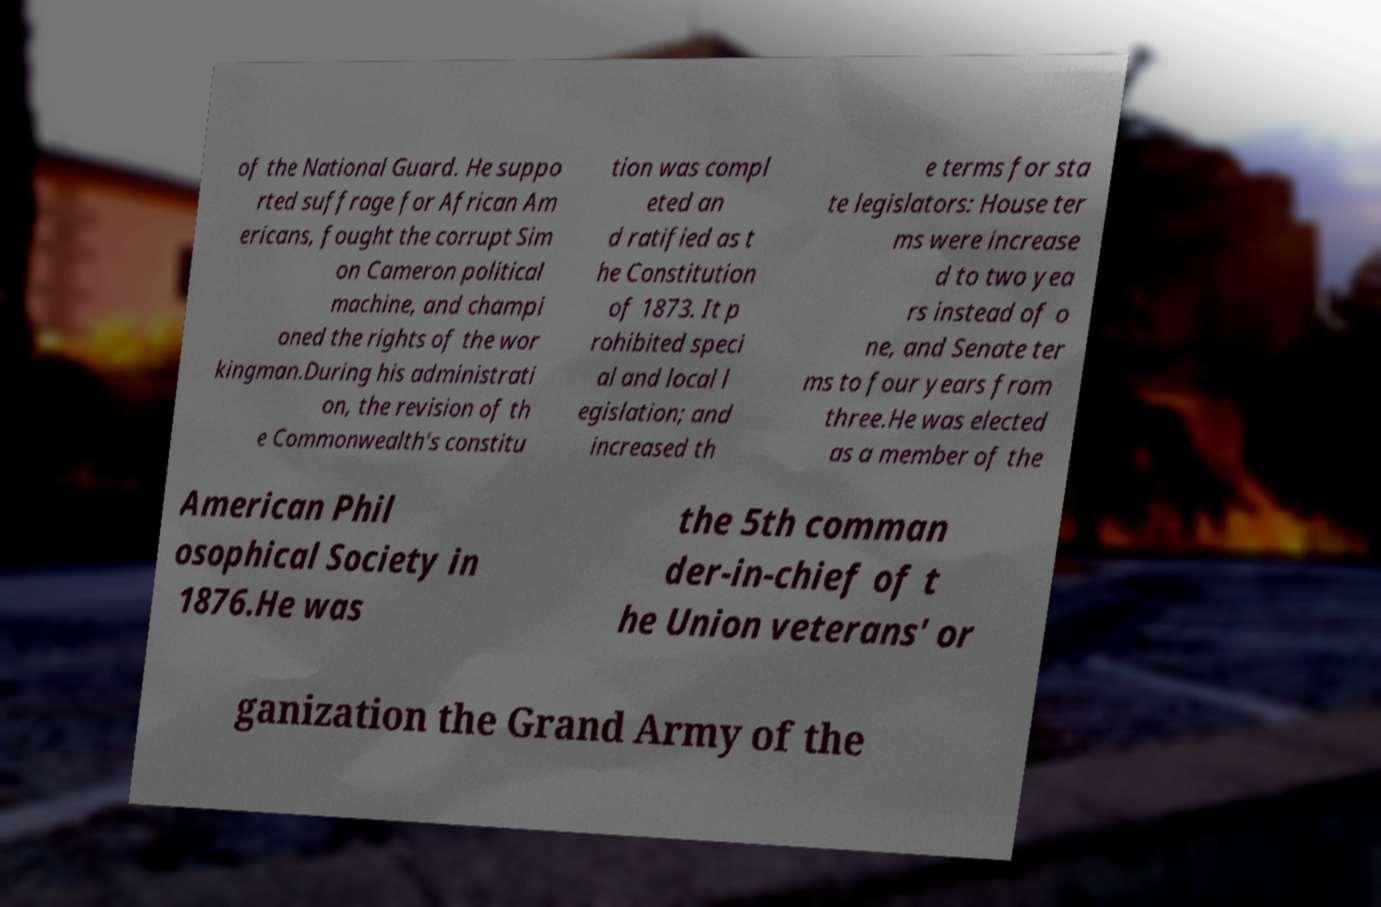I need the written content from this picture converted into text. Can you do that? of the National Guard. He suppo rted suffrage for African Am ericans, fought the corrupt Sim on Cameron political machine, and champi oned the rights of the wor kingman.During his administrati on, the revision of th e Commonwealth's constitu tion was compl eted an d ratified as t he Constitution of 1873. It p rohibited speci al and local l egislation; and increased th e terms for sta te legislators: House ter ms were increase d to two yea rs instead of o ne, and Senate ter ms to four years from three.He was elected as a member of the American Phil osophical Society in 1876.He was the 5th comman der-in-chief of t he Union veterans' or ganization the Grand Army of the 